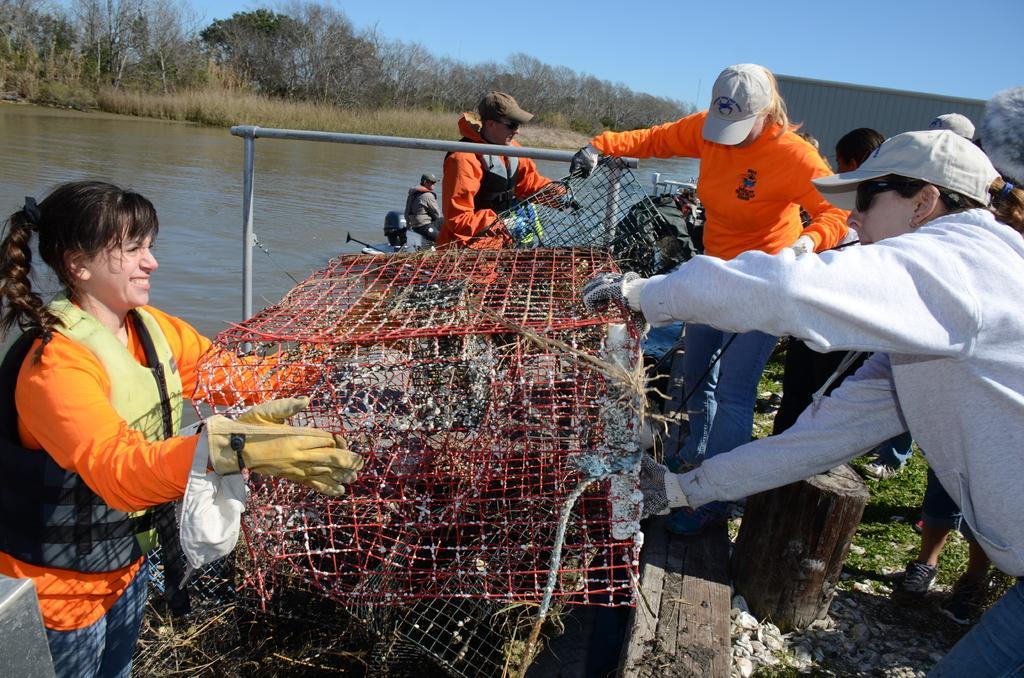Please provide a concise description of this image. In this image, on the right side, we can see a group of people standing. On the left side, we can see a woman standing and holding a net fence. In the background, we can see a metal rod, a group of people, building, trees. At the top, we can see a sky, at the bottom, we can see a water in a lake and a grass. 